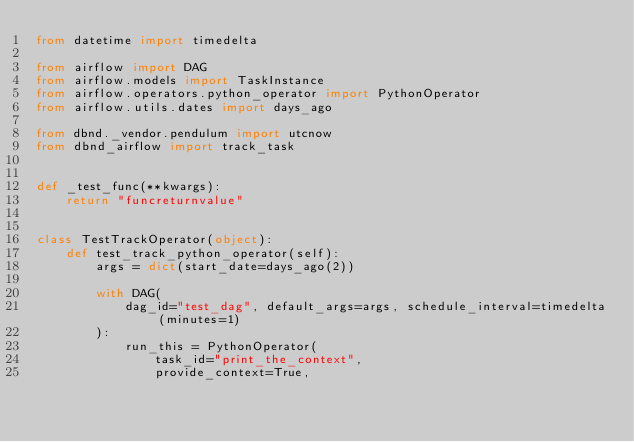<code> <loc_0><loc_0><loc_500><loc_500><_Python_>from datetime import timedelta

from airflow import DAG
from airflow.models import TaskInstance
from airflow.operators.python_operator import PythonOperator
from airflow.utils.dates import days_ago

from dbnd._vendor.pendulum import utcnow
from dbnd_airflow import track_task


def _test_func(**kwargs):
    return "funcreturnvalue"


class TestTrackOperator(object):
    def test_track_python_operator(self):
        args = dict(start_date=days_ago(2))

        with DAG(
            dag_id="test_dag", default_args=args, schedule_interval=timedelta(minutes=1)
        ):
            run_this = PythonOperator(
                task_id="print_the_context",
                provide_context=True,</code> 